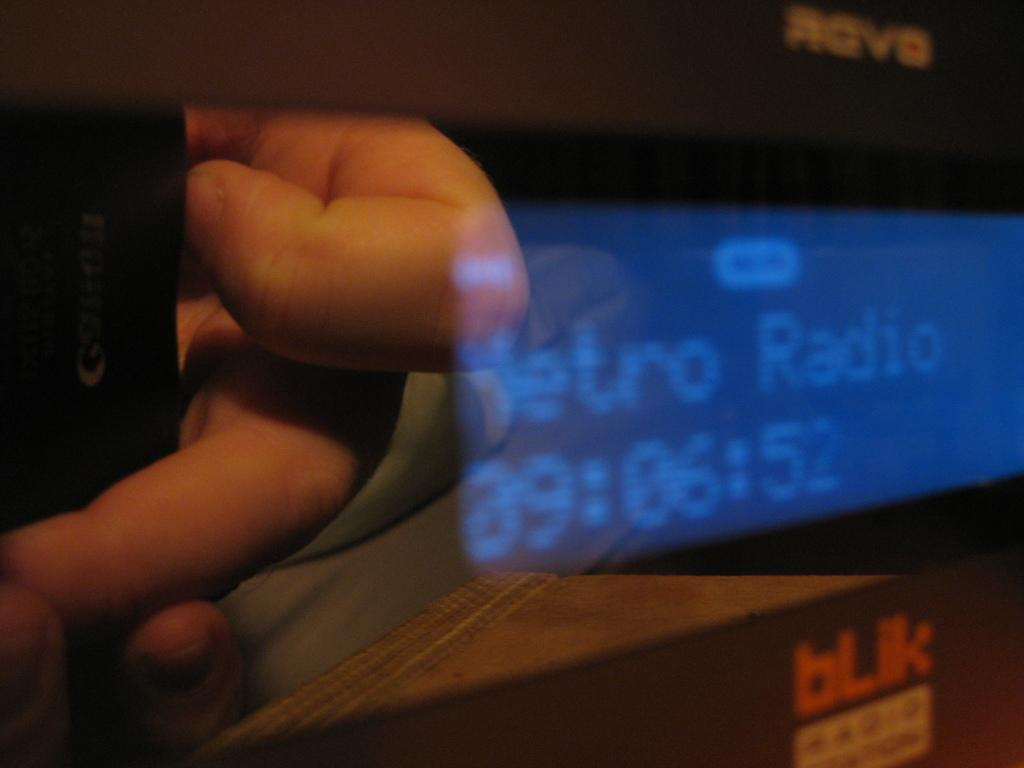What can be seen on the left side of the image? There is a person's hand on the left side of the image. What is located on the right side of the image? There is a screen on the right side of the image. What type of basin is visible on the edge of the screen in the image? There is no basin present in the image, and the screen does not have an edge. 